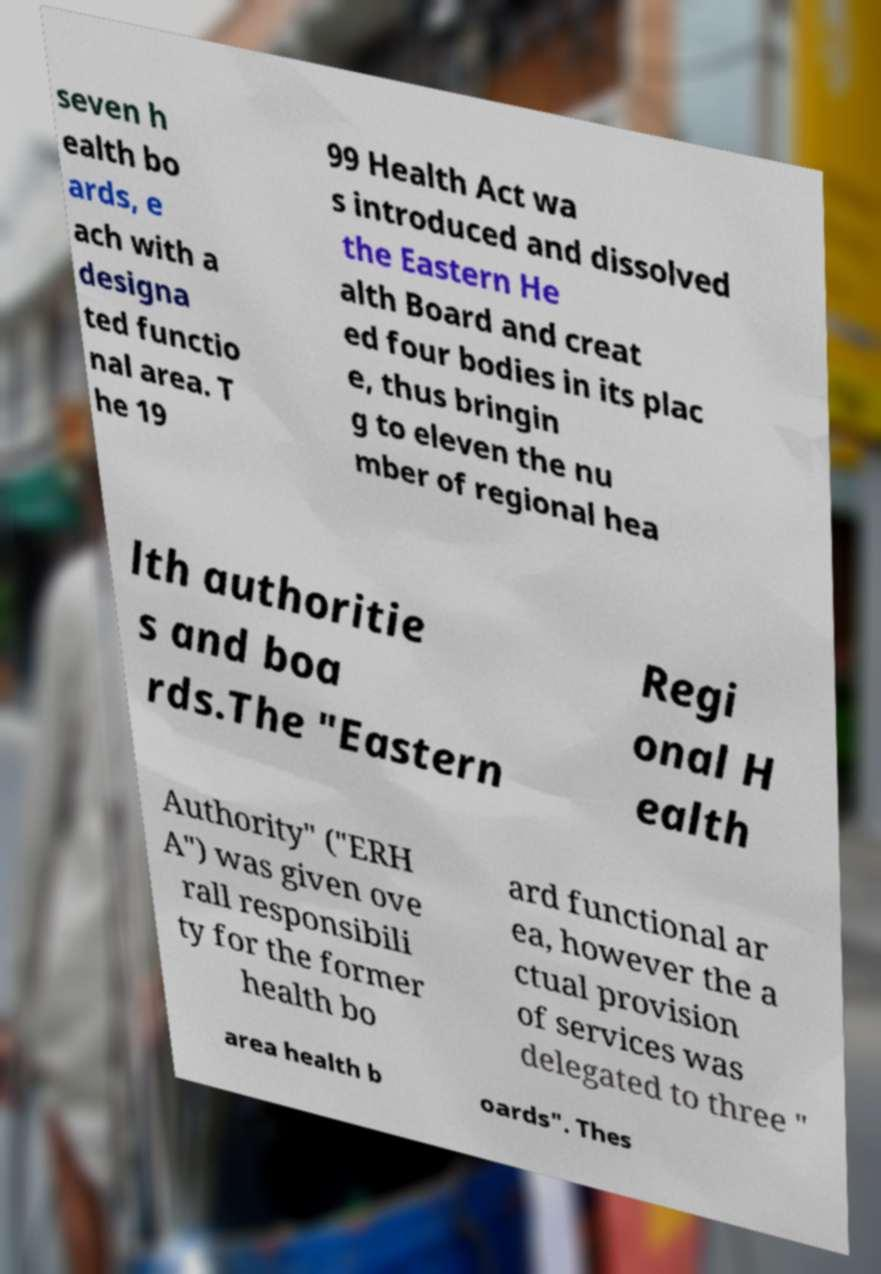Please identify and transcribe the text found in this image. seven h ealth bo ards, e ach with a designa ted functio nal area. T he 19 99 Health Act wa s introduced and dissolved the Eastern He alth Board and creat ed four bodies in its plac e, thus bringin g to eleven the nu mber of regional hea lth authoritie s and boa rds.The "Eastern Regi onal H ealth Authority" ("ERH A") was given ove rall responsibili ty for the former health bo ard functional ar ea, however the a ctual provision of services was delegated to three " area health b oards". Thes 